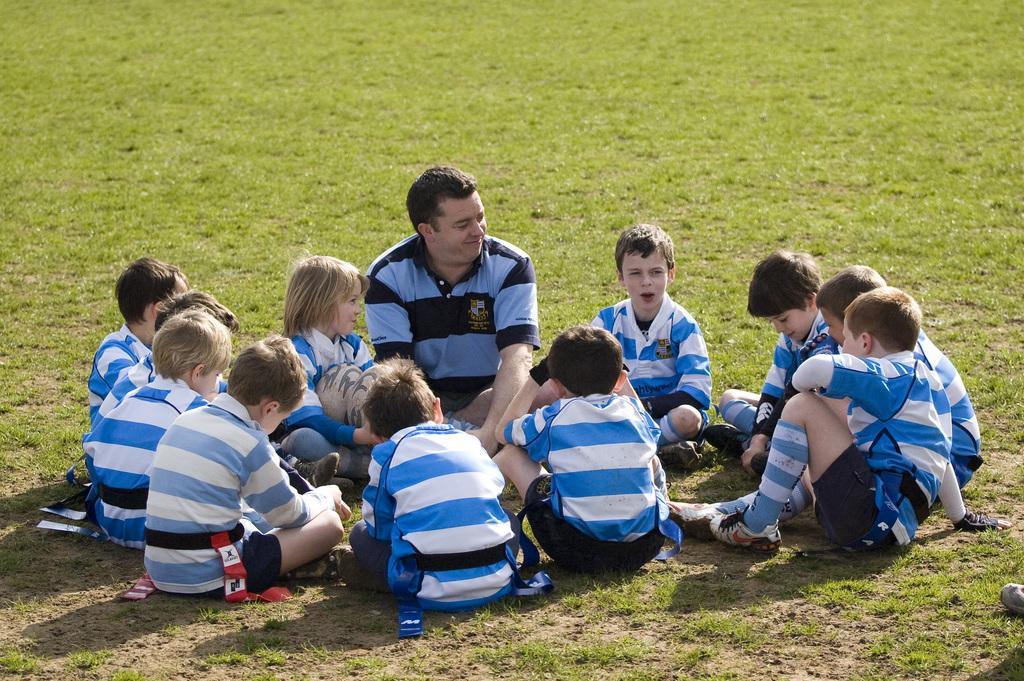Please provide a concise description of this image. In this image I can see few people are sitting on the ground. One man is wearing t-shirt and smiling. And the remaining kids are looking at this boy. The boy who is sitting right side of the man is holding a ball in his hands. 